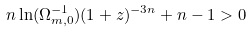<formula> <loc_0><loc_0><loc_500><loc_500>n \ln ( \Omega _ { m , 0 } ^ { - 1 } ) ( 1 + z ) ^ { - 3 n } + n - 1 > 0</formula> 